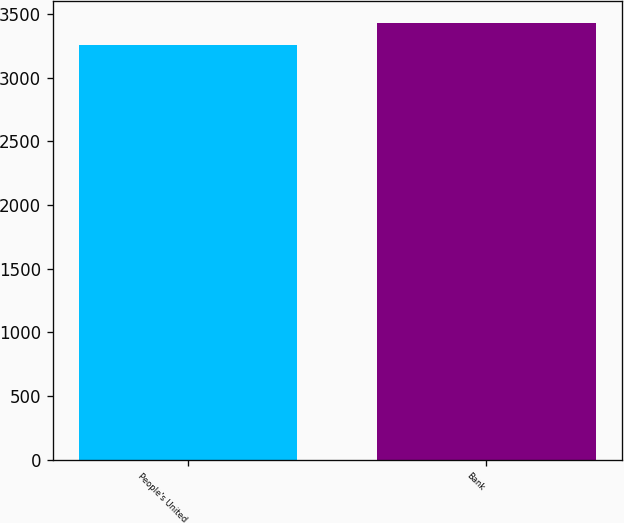Convert chart. <chart><loc_0><loc_0><loc_500><loc_500><bar_chart><fcel>People's United<fcel>Bank<nl><fcel>3256.1<fcel>3430.5<nl></chart> 